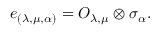<formula> <loc_0><loc_0><loc_500><loc_500>e _ { ( \lambda , \mu , \alpha ) } = O _ { \lambda , \mu } \otimes \sigma _ { \alpha } .</formula> 